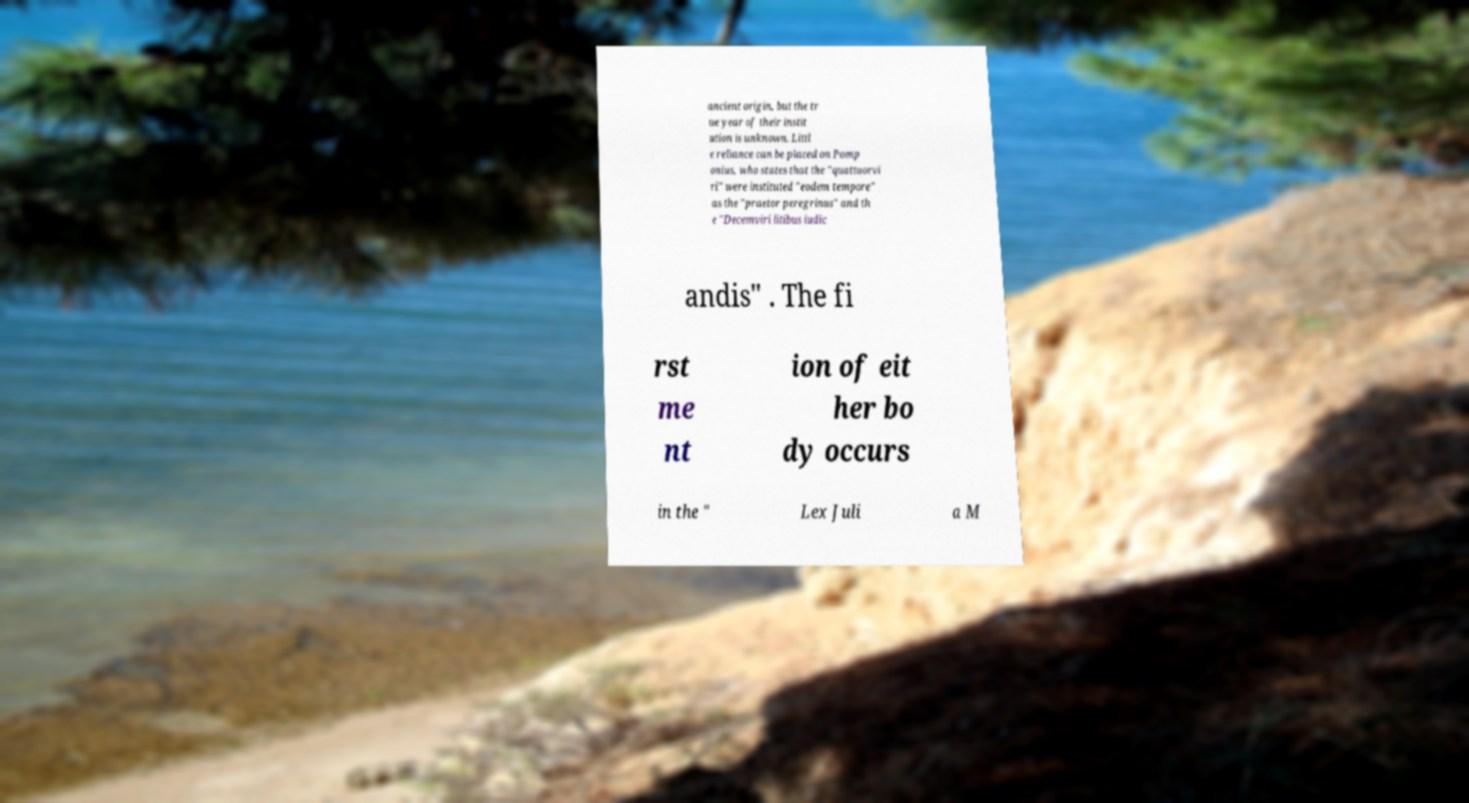Can you accurately transcribe the text from the provided image for me? ancient origin, but the tr ue year of their instit ution is unknown. Littl e reliance can be placed on Pomp onius, who states that the "quattuorvi ri" were instituted "eodem tempore" as the "praetor peregrinus" and th e "Decemviri litibus iudic andis" . The fi rst me nt ion of eit her bo dy occurs in the " Lex Juli a M 